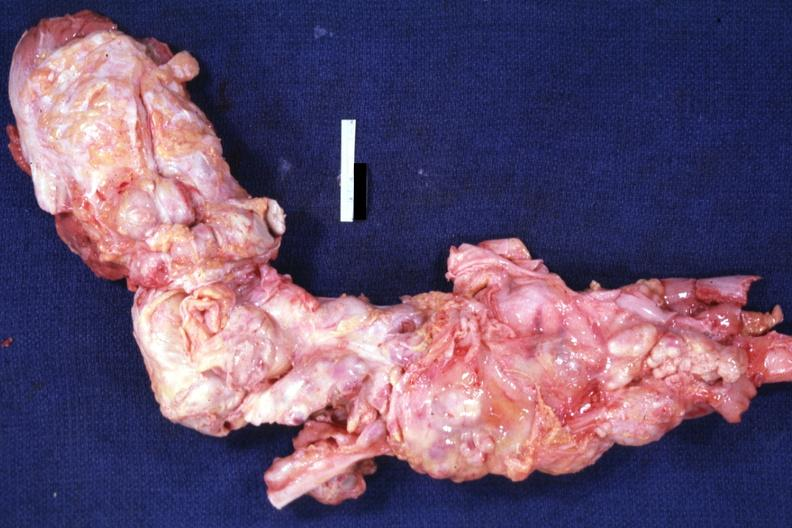does this image show aorta not opened surrounded by large nodes?
Answer the question using a single word or phrase. Yes 